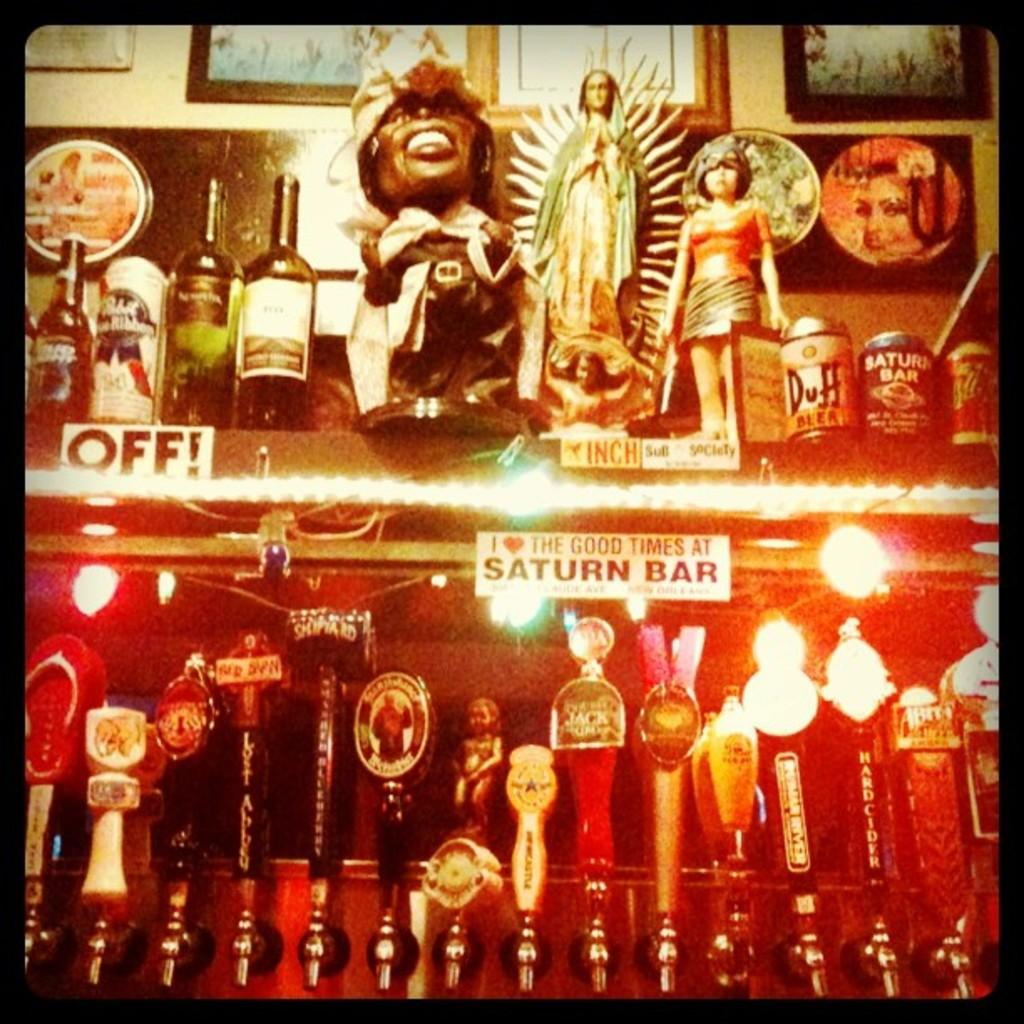<image>
Offer a succinct explanation of the picture presented. a sign above a bar that says 'i love the good times at saturn bar' on it 